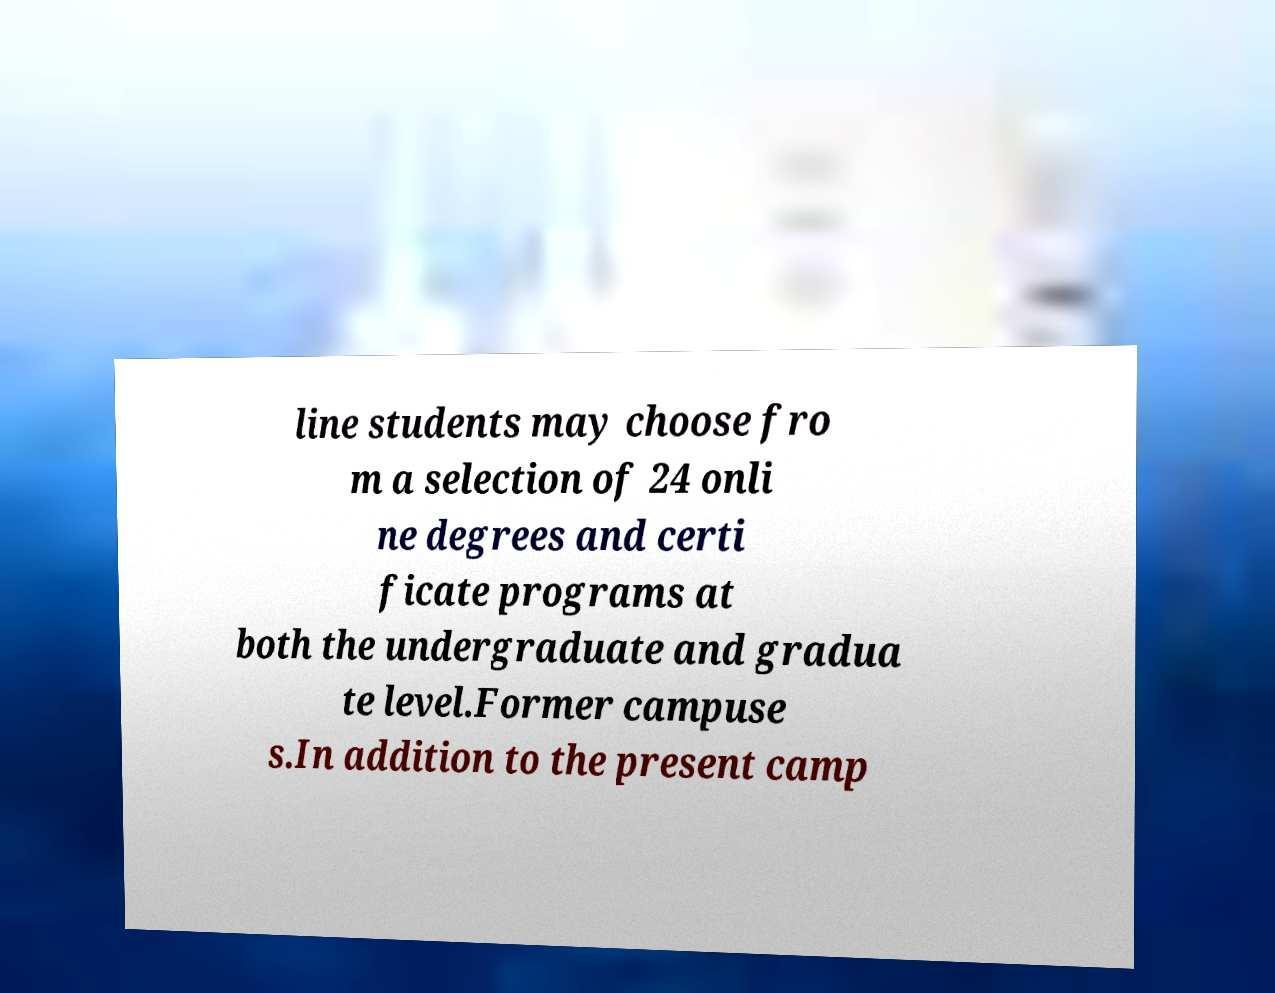I need the written content from this picture converted into text. Can you do that? line students may choose fro m a selection of 24 onli ne degrees and certi ficate programs at both the undergraduate and gradua te level.Former campuse s.In addition to the present camp 